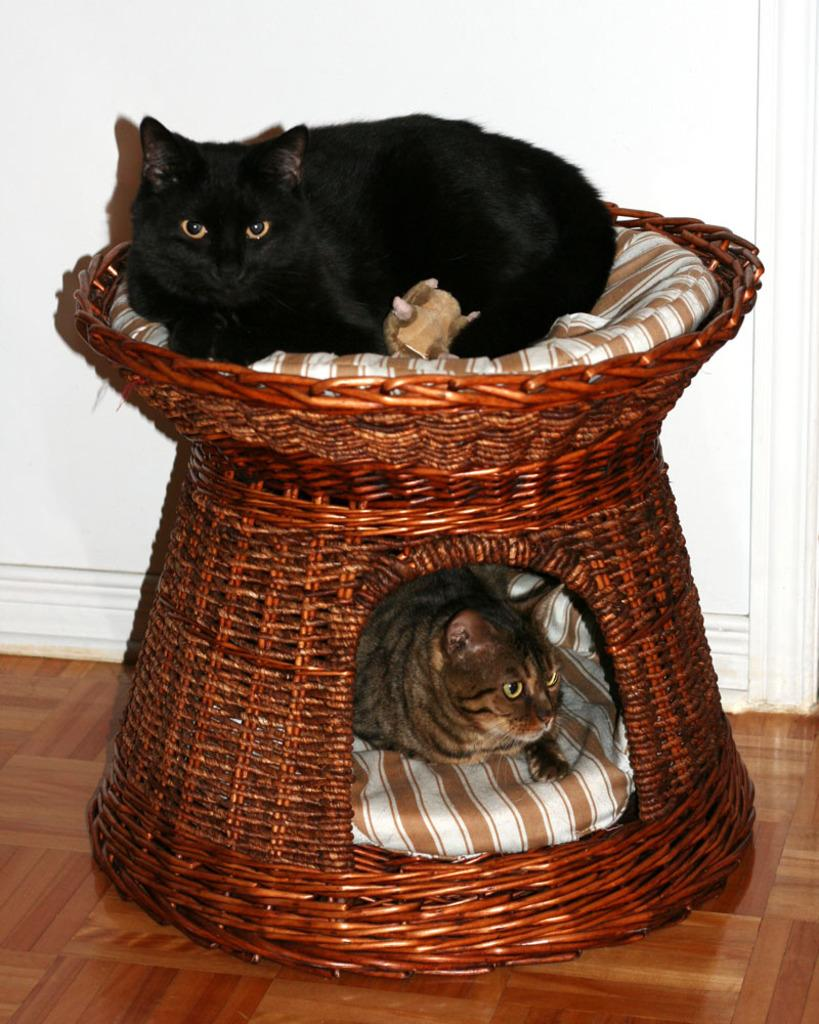What type of animals are in the image? There are cats in the image. What are the cats doing in the image? The cats are sleeping in the image. Where are the cats located in the image? The cats are in a basket in the image. What is the source of anger in the image? There is no indication of anger in the image; the cats are sleeping peacefully. Can you tell me how many sheep are present in the image? There are no sheep present in the image; it features cats in a basket. 